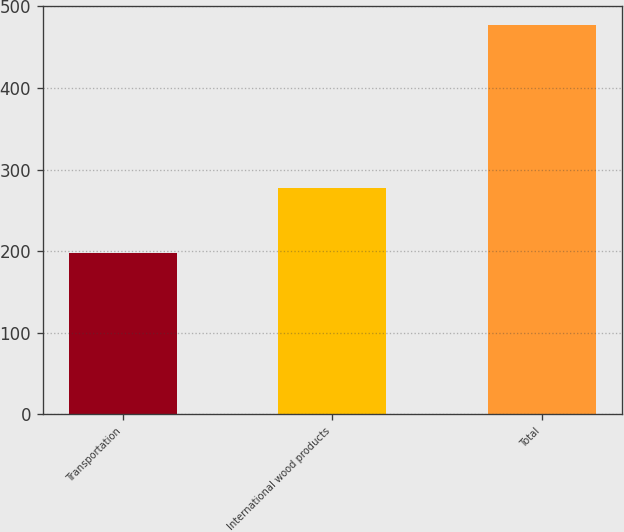Convert chart to OTSL. <chart><loc_0><loc_0><loc_500><loc_500><bar_chart><fcel>Transportation<fcel>International wood products<fcel>Total<nl><fcel>198<fcel>277<fcel>477<nl></chart> 